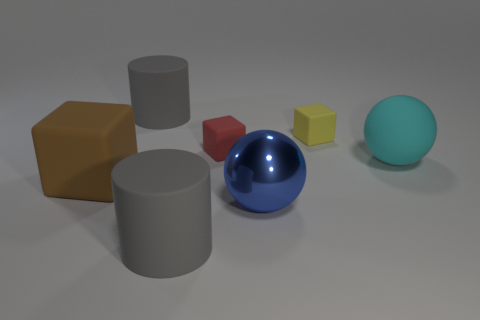Does the yellow rubber block have the same size as the rubber cylinder in front of the tiny yellow thing?
Make the answer very short. No. How many things are metal cylinders or large things?
Offer a terse response. 5. How many big matte objects are the same color as the big metallic ball?
Provide a short and direct response. 0. There is a blue object that is the same size as the brown rubber cube; what shape is it?
Your answer should be very brief. Sphere. Is there a small purple thing that has the same shape as the tiny red object?
Give a very brief answer. No. How many balls have the same material as the large block?
Offer a terse response. 1. Are the large cylinder behind the blue thing and the blue thing made of the same material?
Your response must be concise. No. Is the number of tiny red matte blocks that are behind the big blue sphere greater than the number of gray objects on the left side of the large brown matte thing?
Your answer should be compact. Yes. There is another brown thing that is the same size as the metal object; what material is it?
Ensure brevity in your answer.  Rubber. How many other objects are the same material as the yellow block?
Ensure brevity in your answer.  5. 